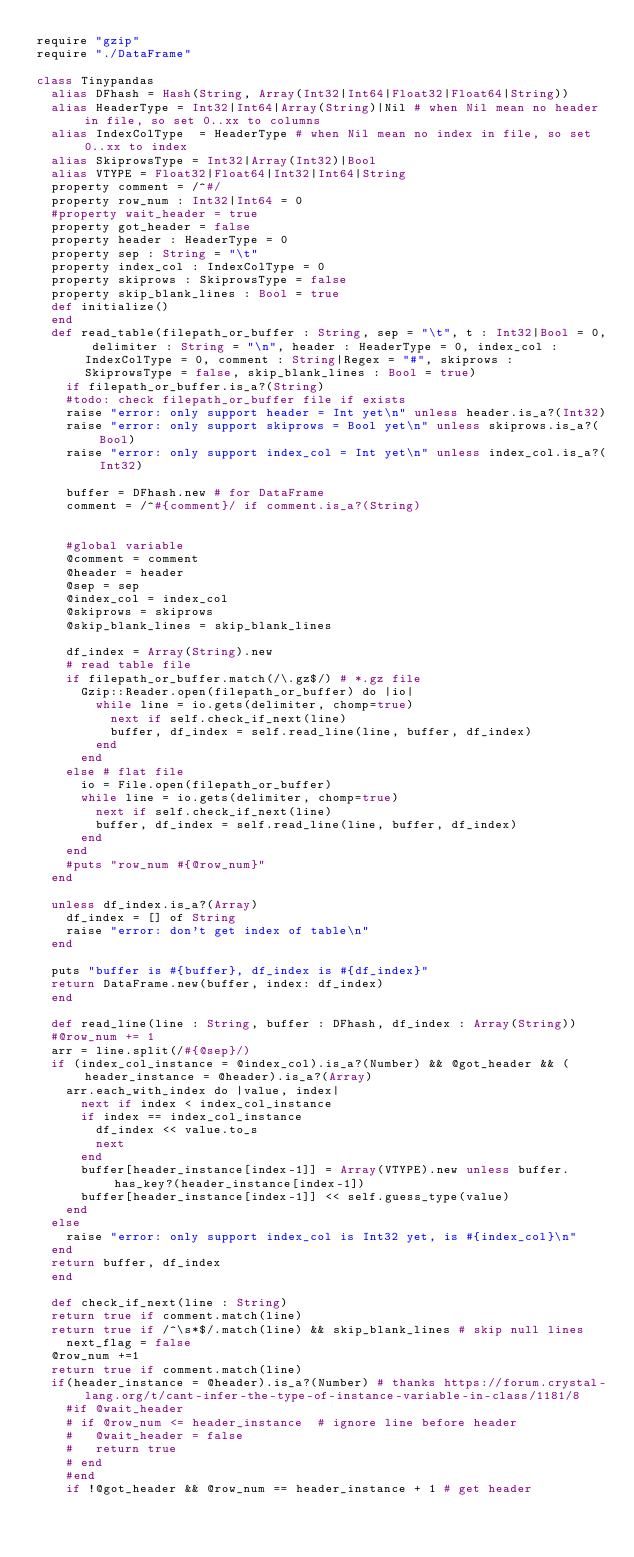Convert code to text. <code><loc_0><loc_0><loc_500><loc_500><_Crystal_>require "gzip"
require "./DataFrame"

class Tinypandas
  alias DFhash = Hash(String, Array(Int32|Int64|Float32|Float64|String))
  alias HeaderType = Int32|Int64|Array(String)|Nil # when Nil mean no header in file, so set 0..xx to columns
  alias IndexColType  = HeaderType # when Nil mean no index in file, so set 0..xx to index
  alias SkiprowsType = Int32|Array(Int32)|Bool
  alias VTYPE = Float32|Float64|Int32|Int64|String
  property comment = /^#/
  property row_num : Int32|Int64 = 0
  #property wait_header = true
  property got_header = false
  property header : HeaderType = 0
  property sep : String = "\t"
  property index_col : IndexColType = 0
  property skiprows : SkiprowsType = false
  property skip_blank_lines : Bool = true
  def initialize()
  end
  def read_table(filepath_or_buffer : String, sep = "\t", t : Int32|Bool = 0, delimiter : String = "\n", header : HeaderType = 0, index_col : IndexColType = 0, comment : String|Regex = "#", skiprows : SkiprowsType = false, skip_blank_lines : Bool = true)
	  if filepath_or_buffer.is_a?(String)
		#todo: check filepath_or_buffer file if exists
		raise "error: only support header = Int yet\n" unless header.is_a?(Int32)
		raise "error: only support skiprows = Bool yet\n" unless skiprows.is_a?(Bool)
		raise "error: only support index_col = Int yet\n" unless index_col.is_a?(Int32)
		
		buffer = DFhash.new # for DataFrame
		comment = /^#{comment}/ if comment.is_a?(String)
	
	
		#global variable
		@comment = comment
		@header = header
		@sep = sep
		@index_col = index_col
		@skiprows = skiprows
		@skip_blank_lines = skip_blank_lines
		
		df_index = Array(String).new
		# read table file 
		if filepath_or_buffer.match(/\.gz$/) # *.gz file
			Gzip::Reader.open(filepath_or_buffer) do |io|
				while line = io.gets(delimiter, chomp=true)
					next if self.check_if_next(line)
					buffer, df_index = self.read_line(line, buffer, df_index)
				end
			end
		else # flat file
			io = File.open(filepath_or_buffer)
			while line = io.gets(delimiter, chomp=true)
				next if self.check_if_next(line)
				buffer, df_index = self.read_line(line, buffer, df_index)
			end
		end
		#puts "row_num #{@row_num}"
	end
	
	unless df_index.is_a?(Array)
		df_index = [] of String
		raise "error: don't get index of table\n" 
	end

	puts "buffer is #{buffer}, df_index is #{df_index}"
	return DataFrame.new(buffer, index: df_index)
  end
  
  def read_line(line : String, buffer : DFhash, df_index : Array(String))
	#@row_num += 1
	arr = line.split(/#{@sep}/)
	if (index_col_instance = @index_col).is_a?(Number) && @got_header && (header_instance = @header).is_a?(Array)
		arr.each_with_index do |value, index|
			next if index < index_col_instance
			if index == index_col_instance
				df_index << value.to_s 
				next
			end
			buffer[header_instance[index-1]] = Array(VTYPE).new unless buffer.has_key?(header_instance[index-1])
			buffer[header_instance[index-1]] << self.guess_type(value)
		end
	else
		raise "error: only support index_col is Int32 yet, is #{index_col}\n"
	end
	return buffer, df_index
  end
  
  def check_if_next(line : String)
	return true if comment.match(line)
	return true if /^\s*$/.match(line) && skip_blank_lines # skip null lines
    next_flag = false
	@row_num +=1
	return true if comment.match(line)
	if(header_instance = @header).is_a?(Number) # thanks https://forum.crystal-lang.org/t/cant-infer-the-type-of-instance-variable-in-class/1181/8
		#if @wait_header
		#	if @row_num <= header_instance  # ignore line before header
		#		@wait_header = false
		#		return true
		#	end
		#end
		if !@got_header && @row_num == header_instance + 1 # get header</code> 